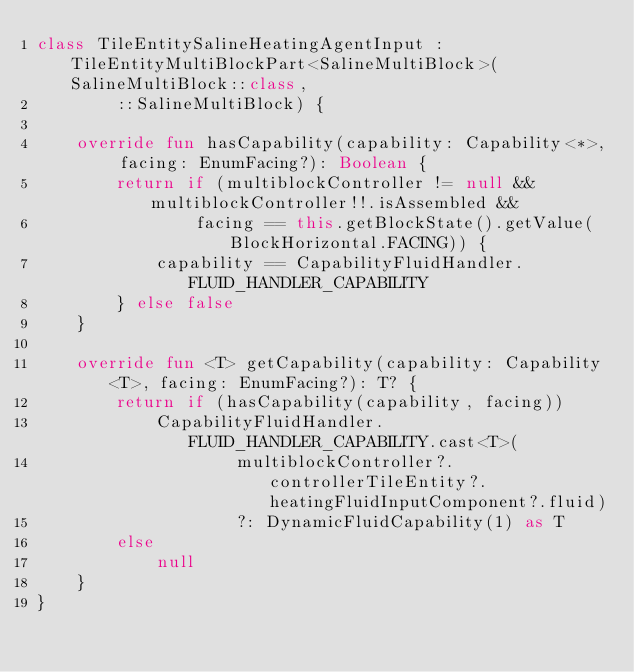<code> <loc_0><loc_0><loc_500><loc_500><_Kotlin_>class TileEntitySalineHeatingAgentInput : TileEntityMultiBlockPart<SalineMultiBlock>(SalineMultiBlock::class,
        ::SalineMultiBlock) {

    override fun hasCapability(capability: Capability<*>, facing: EnumFacing?): Boolean {
        return if (multiblockController != null && multiblockController!!.isAssembled &&
                facing == this.getBlockState().getValue(BlockHorizontal.FACING)) {
            capability == CapabilityFluidHandler.FLUID_HANDLER_CAPABILITY
        } else false
    }

    override fun <T> getCapability(capability: Capability<T>, facing: EnumFacing?): T? {
        return if (hasCapability(capability, facing))
            CapabilityFluidHandler.FLUID_HANDLER_CAPABILITY.cast<T>(
                    multiblockController?.controllerTileEntity?.heatingFluidInputComponent?.fluid)
                    ?: DynamicFluidCapability(1) as T
        else
            null
    }
}</code> 